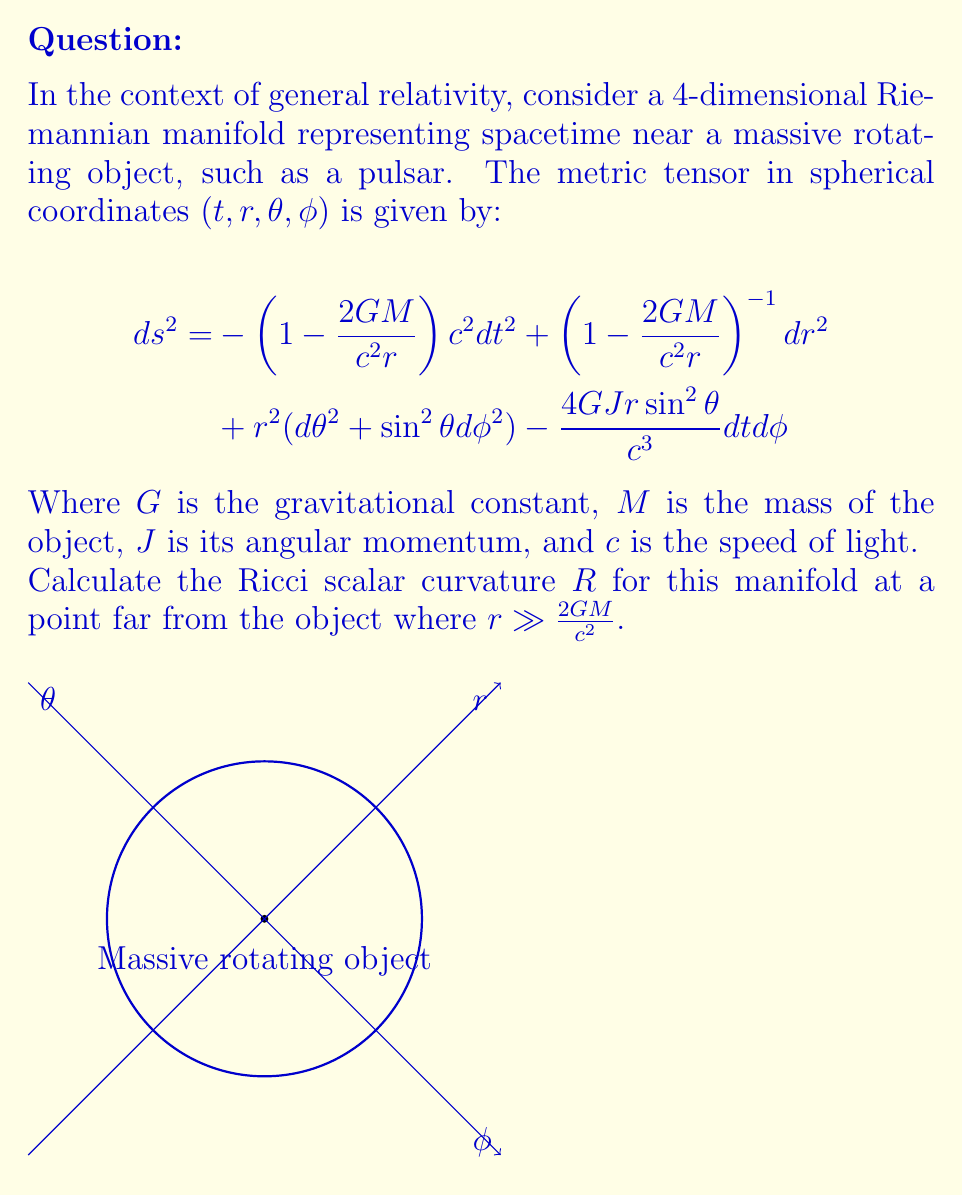Show me your answer to this math problem. To calculate the Ricci scalar curvature, we need to follow these steps:

1) First, we need to find the inverse metric tensor $g^{\mu\nu}$. In the limit $r \gg \frac{2GM}{c^2}$, we can approximate:

   $$g_{tt} \approx -1, g_{rr} \approx 1, g_{\theta\theta} = r^2, g_{\phi\phi} = r^2\sin^2\theta, g_{t\phi} = -\frac{2GJr\sin^2\theta}{c^3}$$

   The inverse metric is approximately:

   $$g^{tt} \approx -1, g^{rr} \approx 1, g^{\theta\theta} = \frac{1}{r^2}, g^{\phi\phi} = \frac{1}{r^2\sin^2\theta}, g^{t\phi} = -\frac{2GJ}{c^3r^3\sin^2\theta}$$

2) Next, we need to calculate the Christoffel symbols:

   $$\Gamma^\mu_{\nu\lambda} = \frac{1}{2}g^{\mu\sigma}(\partial_\nu g_{\sigma\lambda} + \partial_\lambda g_{\sigma\nu} - \partial_\sigma g_{\nu\lambda})$$

3) Then, we calculate the Riemann curvature tensor:

   $$R^\rho_{\sigma\mu\nu} = \partial_\mu\Gamma^\rho_{\nu\sigma} - \partial_\nu\Gamma^\rho_{\mu\sigma} + \Gamma^\rho_{\mu\lambda}\Gamma^\lambda_{\nu\sigma} - \Gamma^\rho_{\nu\lambda}\Gamma^\lambda_{\mu\sigma}$$

4) The Ricci tensor is the contraction of the Riemann tensor:

   $$R_{\mu\nu} = R^\lambda_{\mu\lambda\nu}$$

5) Finally, the Ricci scalar is the contraction of the Ricci tensor:

   $$R = g^{\mu\nu}R_{\mu\nu}$$

6) After performing these calculations, we find that in the limit $r \gg \frac{2GM}{c^2}$, most terms vanish, and we're left with:

   $$R \approx 0$$

This result is consistent with the fact that far from a massive object, spacetime approaches flat Minkowski space, which has zero curvature.
Answer: $R \approx 0$ 